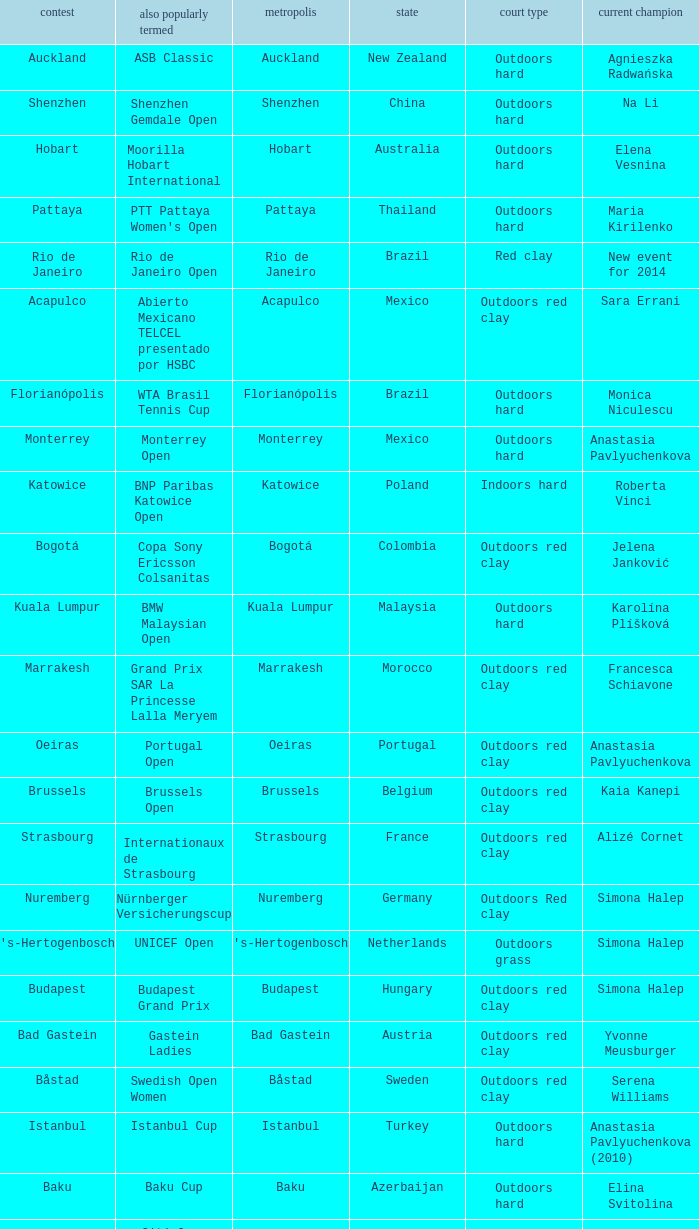What tournament is in katowice? Katowice. 